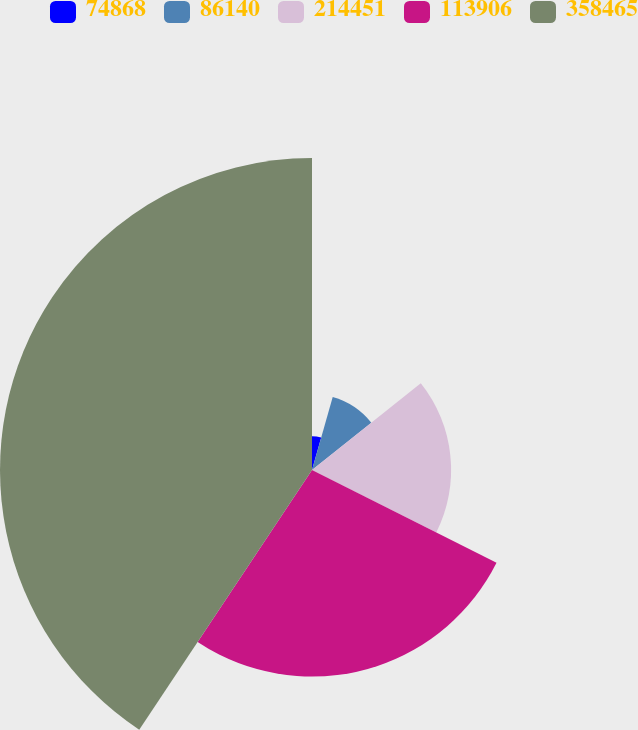<chart> <loc_0><loc_0><loc_500><loc_500><pie_chart><fcel>74868<fcel>86140<fcel>214451<fcel>113906<fcel>358465<nl><fcel>4.4%<fcel>9.89%<fcel>18.13%<fcel>26.92%<fcel>40.66%<nl></chart> 